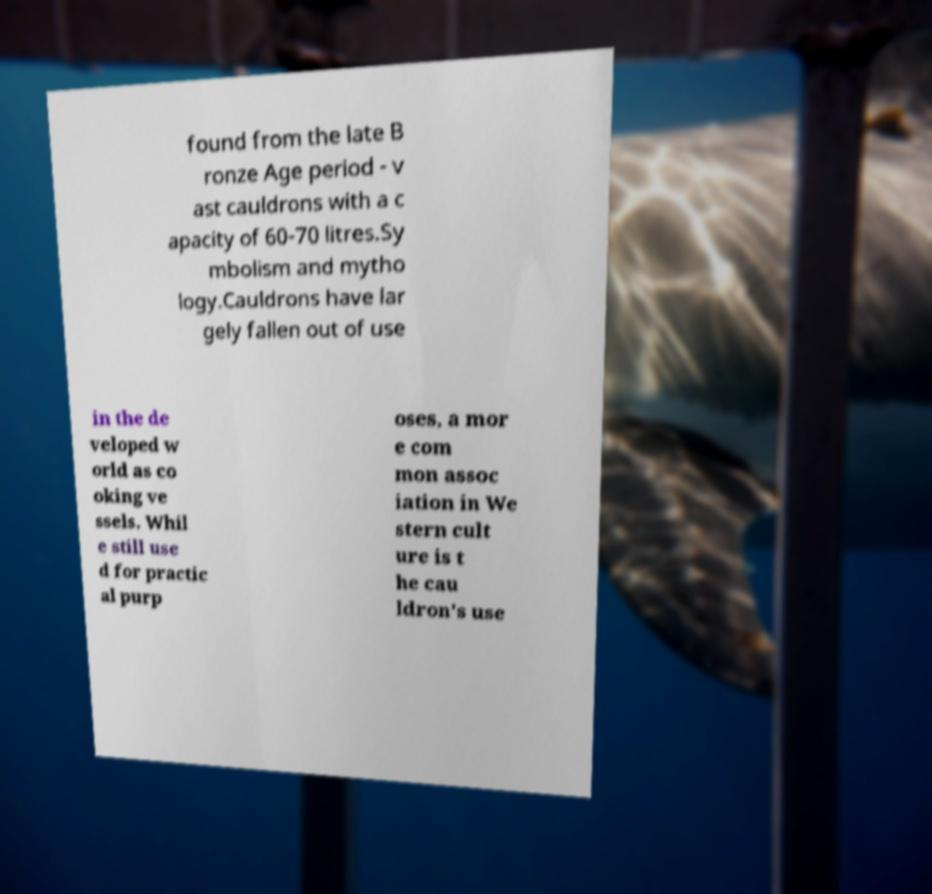Can you read and provide the text displayed in the image?This photo seems to have some interesting text. Can you extract and type it out for me? found from the late B ronze Age period - v ast cauldrons with a c apacity of 60-70 litres.Sy mbolism and mytho logy.Cauldrons have lar gely fallen out of use in the de veloped w orld as co oking ve ssels. Whil e still use d for practic al purp oses, a mor e com mon assoc iation in We stern cult ure is t he cau ldron's use 